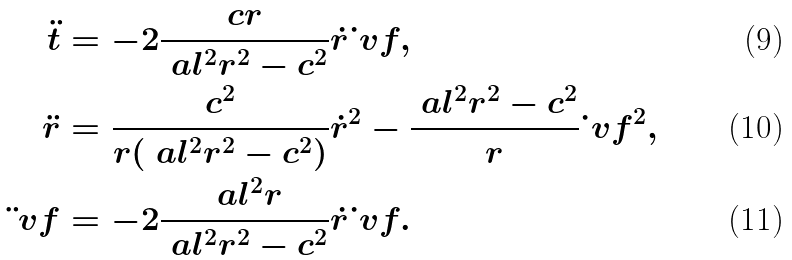<formula> <loc_0><loc_0><loc_500><loc_500>\ddot { t } & = - 2 \frac { c r } { \ a l ^ { 2 } r ^ { 2 } - c ^ { 2 } } \dot { r } \dot { \ } v f , \\ \ddot { r } & = \frac { c ^ { 2 } } { r ( \ a l ^ { 2 } r ^ { 2 } - c ^ { 2 } ) } \dot { r } ^ { 2 } - \frac { \ a l ^ { 2 } r ^ { 2 } - c ^ { 2 } } r \dot { \ } v f ^ { 2 } , \\ \ddot { \ } v f & = - 2 \frac { \ a l ^ { 2 } r } { \ a l ^ { 2 } r ^ { 2 } - c ^ { 2 } } \dot { r } \dot { \ } v f .</formula> 